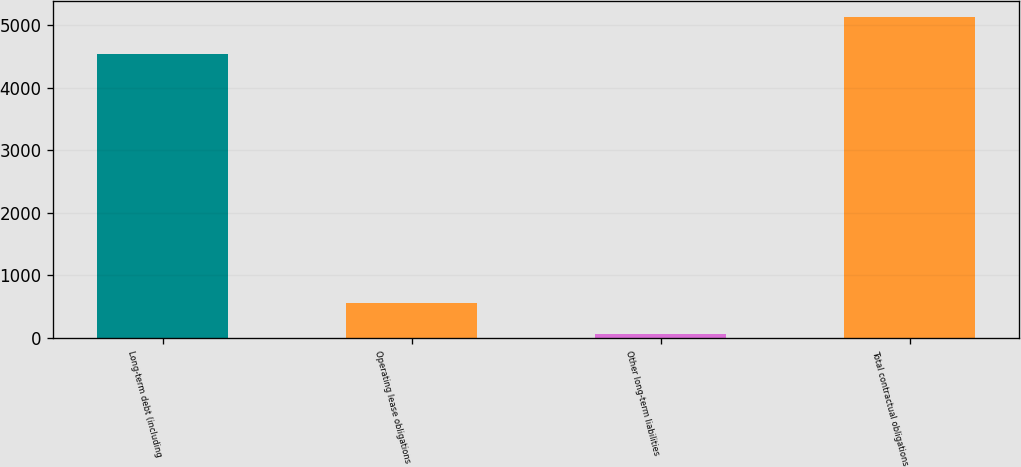<chart> <loc_0><loc_0><loc_500><loc_500><bar_chart><fcel>Long-term debt (including<fcel>Operating lease obligations<fcel>Other long-term liabilities<fcel>Total contractual obligations<nl><fcel>4536<fcel>566.1<fcel>60<fcel>5121<nl></chart> 